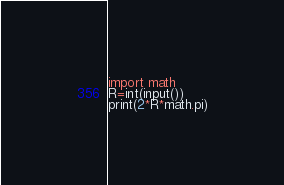<code> <loc_0><loc_0><loc_500><loc_500><_Python_>import math
R=int(input())
print(2*R*math.pi)</code> 